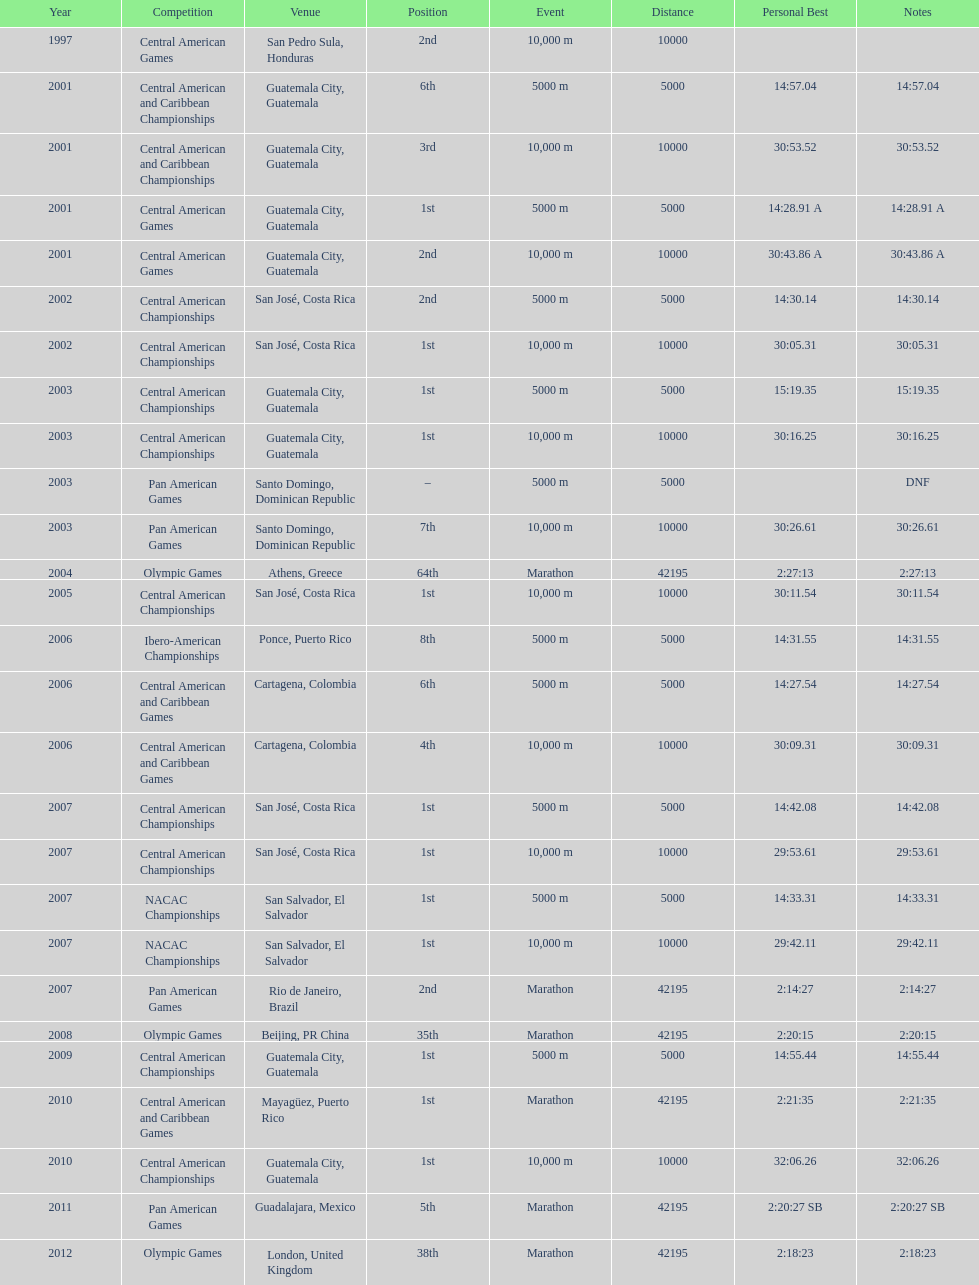Which of each game in 2007 was in the 2nd position? Pan American Games. 